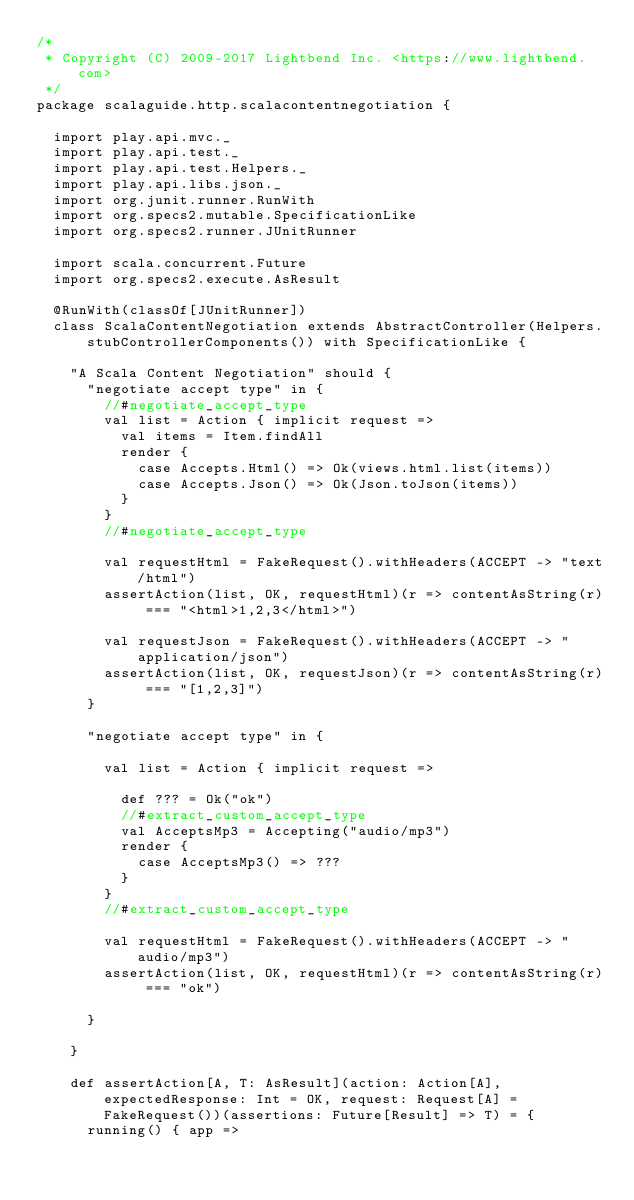<code> <loc_0><loc_0><loc_500><loc_500><_Scala_>/*
 * Copyright (C) 2009-2017 Lightbend Inc. <https://www.lightbend.com>
 */
package scalaguide.http.scalacontentnegotiation {

  import play.api.mvc._
  import play.api.test._
  import play.api.test.Helpers._
  import play.api.libs.json._
  import org.junit.runner.RunWith
  import org.specs2.mutable.SpecificationLike
  import org.specs2.runner.JUnitRunner

  import scala.concurrent.Future
  import org.specs2.execute.AsResult

  @RunWith(classOf[JUnitRunner])
  class ScalaContentNegotiation extends AbstractController(Helpers.stubControllerComponents()) with SpecificationLike {

    "A Scala Content Negotiation" should {
      "negotiate accept type" in {
        //#negotiate_accept_type
        val list = Action { implicit request =>
          val items = Item.findAll
          render {
            case Accepts.Html() => Ok(views.html.list(items))
            case Accepts.Json() => Ok(Json.toJson(items))
          }
        }
        //#negotiate_accept_type

        val requestHtml = FakeRequest().withHeaders(ACCEPT -> "text/html")
        assertAction(list, OK, requestHtml)(r => contentAsString(r) === "<html>1,2,3</html>")

        val requestJson = FakeRequest().withHeaders(ACCEPT -> "application/json")
        assertAction(list, OK, requestJson)(r => contentAsString(r) === "[1,2,3]")
      }

      "negotiate accept type" in {
        
        val list = Action { implicit request =>

          def ??? = Ok("ok")
          //#extract_custom_accept_type
          val AcceptsMp3 = Accepting("audio/mp3")
          render {
            case AcceptsMp3() => ???
          }
        }
        //#extract_custom_accept_type

        val requestHtml = FakeRequest().withHeaders(ACCEPT -> "audio/mp3")
        assertAction(list, OK, requestHtml)(r => contentAsString(r) === "ok")

      }

    }

    def assertAction[A, T: AsResult](action: Action[A], expectedResponse: Int = OK, request: Request[A] = FakeRequest())(assertions: Future[Result] => T) = {
      running() { app =></code> 